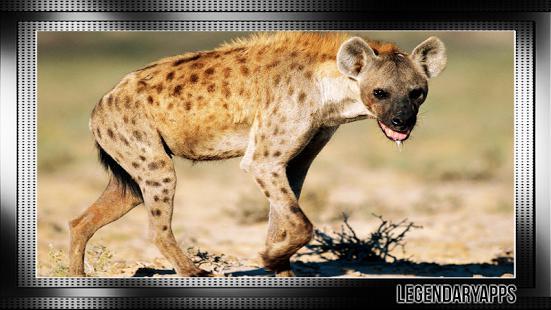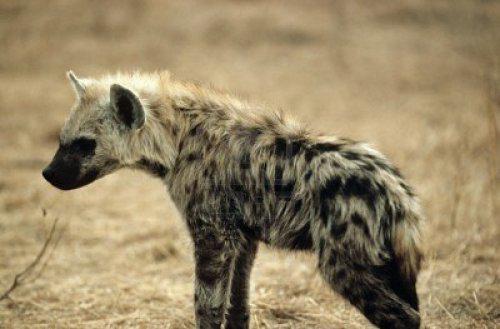The first image is the image on the left, the second image is the image on the right. Considering the images on both sides, is "A hyena has its mouth wide open with sharp teeth visible." valid? Answer yes or no. No. The first image is the image on the left, the second image is the image on the right. For the images shown, is this caption "One image shows a hyena baring its fangs in a wide-opened mouth." true? Answer yes or no. No. 